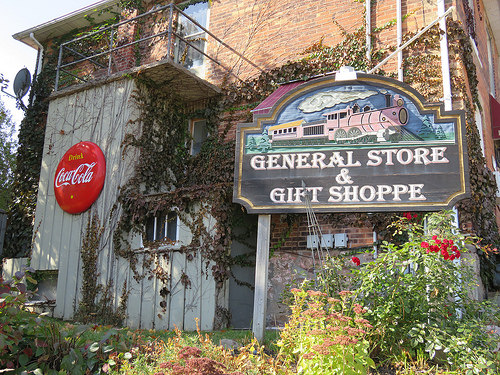<image>
Is the satellite dish above the sign? Yes. The satellite dish is positioned above the sign in the vertical space, higher up in the scene. 